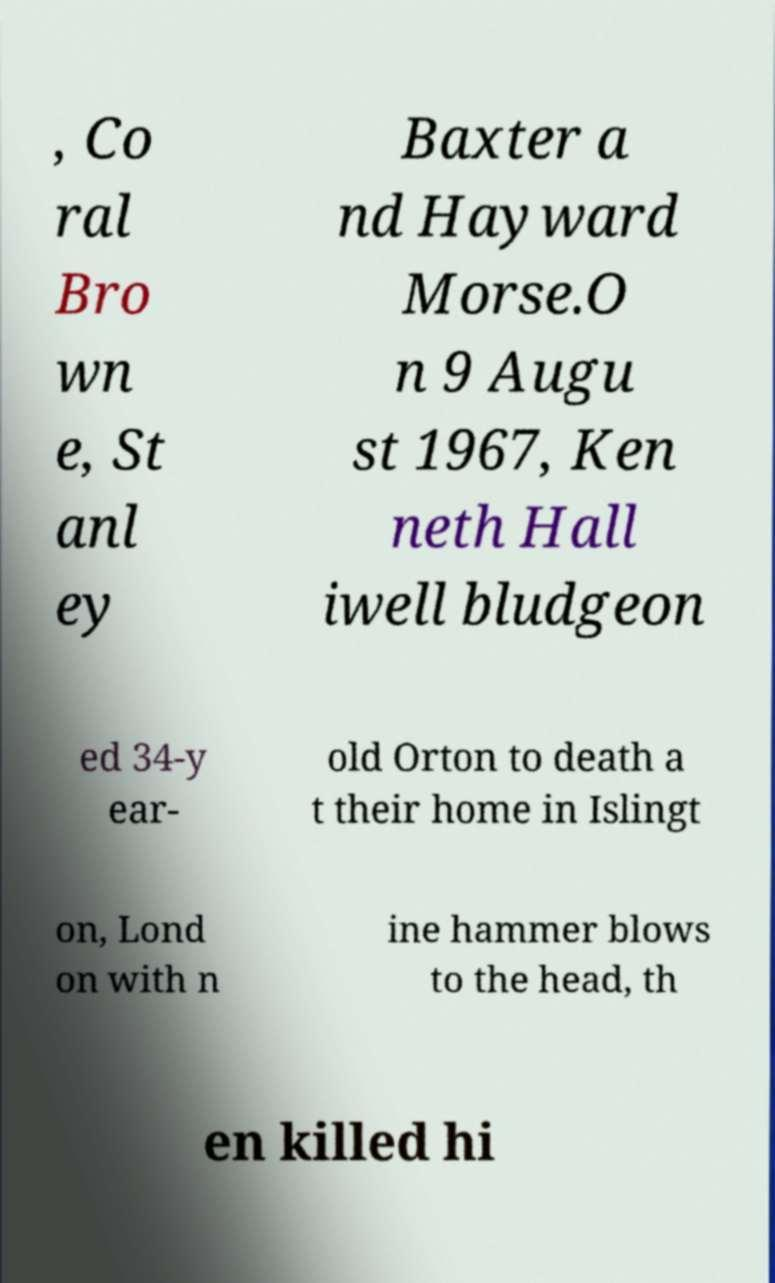Could you extract and type out the text from this image? , Co ral Bro wn e, St anl ey Baxter a nd Hayward Morse.O n 9 Augu st 1967, Ken neth Hall iwell bludgeon ed 34-y ear- old Orton to death a t their home in Islingt on, Lond on with n ine hammer blows to the head, th en killed hi 